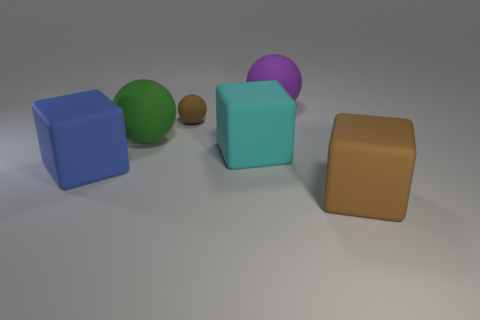Subtract all tiny brown rubber spheres. How many spheres are left? 2 Add 3 small brown objects. How many objects exist? 9 Subtract all brown blocks. How many blocks are left? 2 Subtract all gray cylinders. How many purple spheres are left? 1 Add 6 green spheres. How many green spheres are left? 7 Add 1 big brown blocks. How many big brown blocks exist? 2 Subtract 1 purple spheres. How many objects are left? 5 Subtract 2 cubes. How many cubes are left? 1 Subtract all cyan balls. Subtract all brown blocks. How many balls are left? 3 Subtract all blue cubes. Subtract all large red metallic objects. How many objects are left? 5 